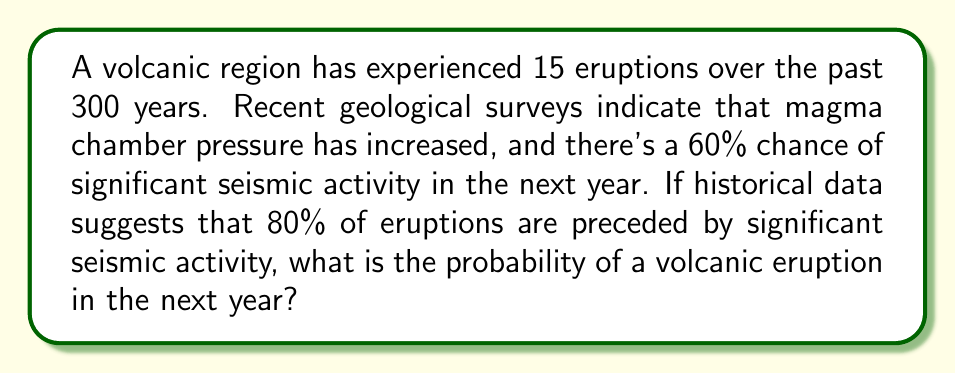Can you answer this question? Let's approach this step-by-step:

1) First, let's calculate the historical probability of an eruption in any given year:
   $$P(\text{Eruption}) = \frac{\text{Number of eruptions}}{\text{Number of years}} = \frac{15}{300} = 0.05 \text{ or } 5\%$$

2) We're given that:
   - $P(\text{Seismic activity}) = 0.60$
   - $P(\text{Eruption | Seismic activity}) = 0.80$ (80% of eruptions are preceded by significant seismic activity)

3) We can use Bayes' theorem to calculate the probability of an eruption given seismic activity:
   $$P(\text{Eruption | Seismic activity}) = \frac{P(\text{Seismic activity | Eruption}) \cdot P(\text{Eruption})}{P(\text{Seismic activity})}$$

4) We know $P(\text{Eruption | Seismic activity})$, but we need $P(\text{Seismic activity | Eruption})$. We can use the given information:
   $$0.80 = \frac{P(\text{Seismic activity | Eruption}) \cdot 0.05}{0.60}$$

5) Solving for $P(\text{Seismic activity | Eruption})$:
   $$P(\text{Seismic activity | Eruption}) = \frac{0.80 \cdot 0.60}{0.05} = 9.6$$

   However, this is impossible as probabilities cannot exceed 1. This suggests that the historical probability of eruption (5%) is too low given the other information.

6) Let's adjust our approach. We know that 80% of eruptions are preceded by seismic activity. So:
   $$P(\text{Eruption | Seismic activity}) \cdot P(\text{Seismic activity}) = 0.80 \cdot P(\text{Eruption})$$

7) Substituting the values:
   $$0.80 \cdot 0.60 = 0.80 \cdot P(\text{Eruption})$$
   $$0.48 = 0.80 \cdot P(\text{Eruption})$$
   $$P(\text{Eruption}) = 0.48 / 0.80 = 0.60 = 60\%$$

8) Therefore, the probability of an eruption in the next year, given the current geological indicators, is 60%.
Answer: 60% 